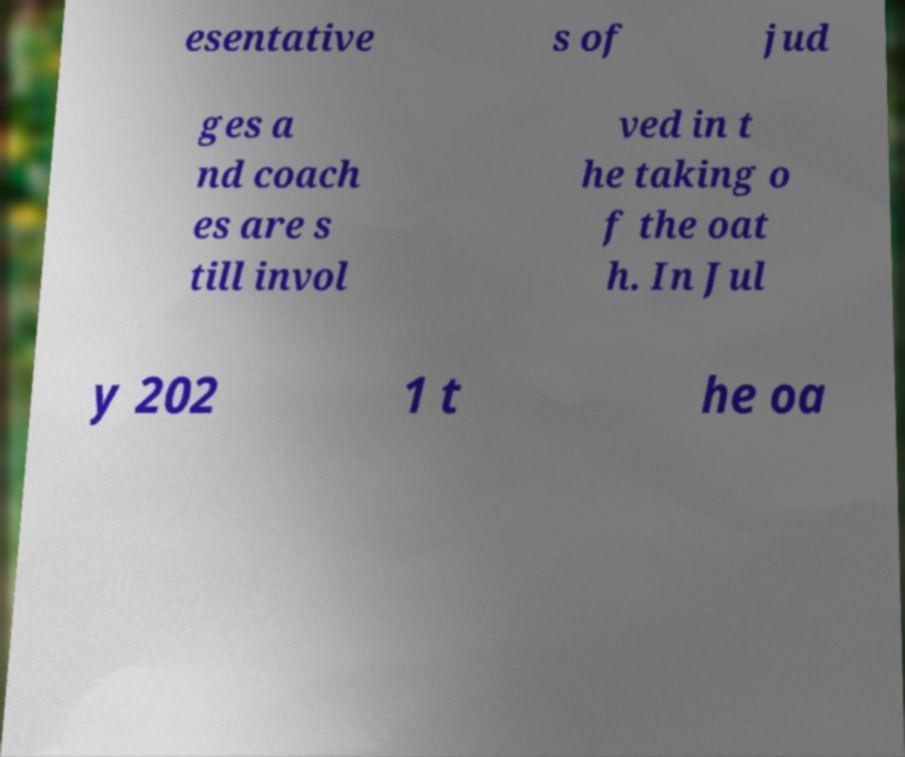I need the written content from this picture converted into text. Can you do that? esentative s of jud ges a nd coach es are s till invol ved in t he taking o f the oat h. In Jul y 202 1 t he oa 